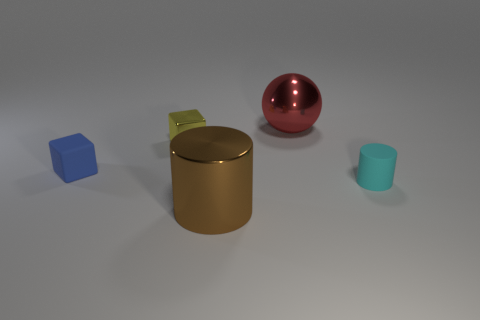There is a rubber cube that is the same size as the rubber cylinder; what is its color?
Provide a succinct answer. Blue. Is there any other thing that is the same color as the tiny matte block?
Keep it short and to the point. No. There is a small object that is right of the large brown thing; what is it made of?
Provide a succinct answer. Rubber. What is the red sphere made of?
Offer a very short reply. Metal. The large thing that is in front of the big thing that is behind the rubber object that is on the right side of the brown cylinder is made of what material?
Make the answer very short. Metal. There is a cyan matte cylinder; is it the same size as the cylinder that is on the left side of the cyan cylinder?
Offer a terse response. No. How many objects are either big metallic objects that are in front of the cyan cylinder or tiny things to the right of the red ball?
Give a very brief answer. 2. What is the color of the metal cylinder that is in front of the tiny blue thing?
Provide a short and direct response. Brown. There is a small rubber thing that is to the left of the cyan object; is there a big metal object in front of it?
Make the answer very short. Yes. Are there fewer big shiny cylinders than brown matte things?
Keep it short and to the point. No. 